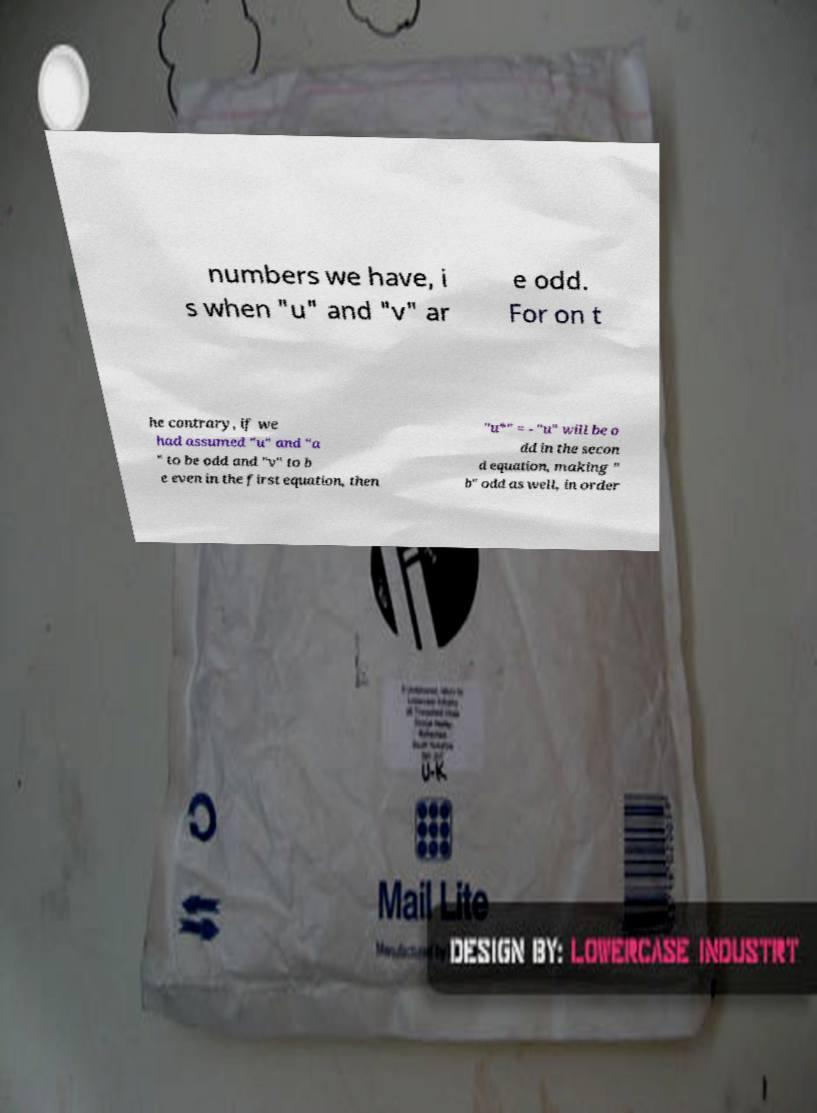Could you extract and type out the text from this image? numbers we have, i s when "u" and "v" ar e odd. For on t he contrary, if we had assumed "u" and "a " to be odd and "v" to b e even in the first equation, then "u*" = - "u" will be o dd in the secon d equation, making " b" odd as well, in order 